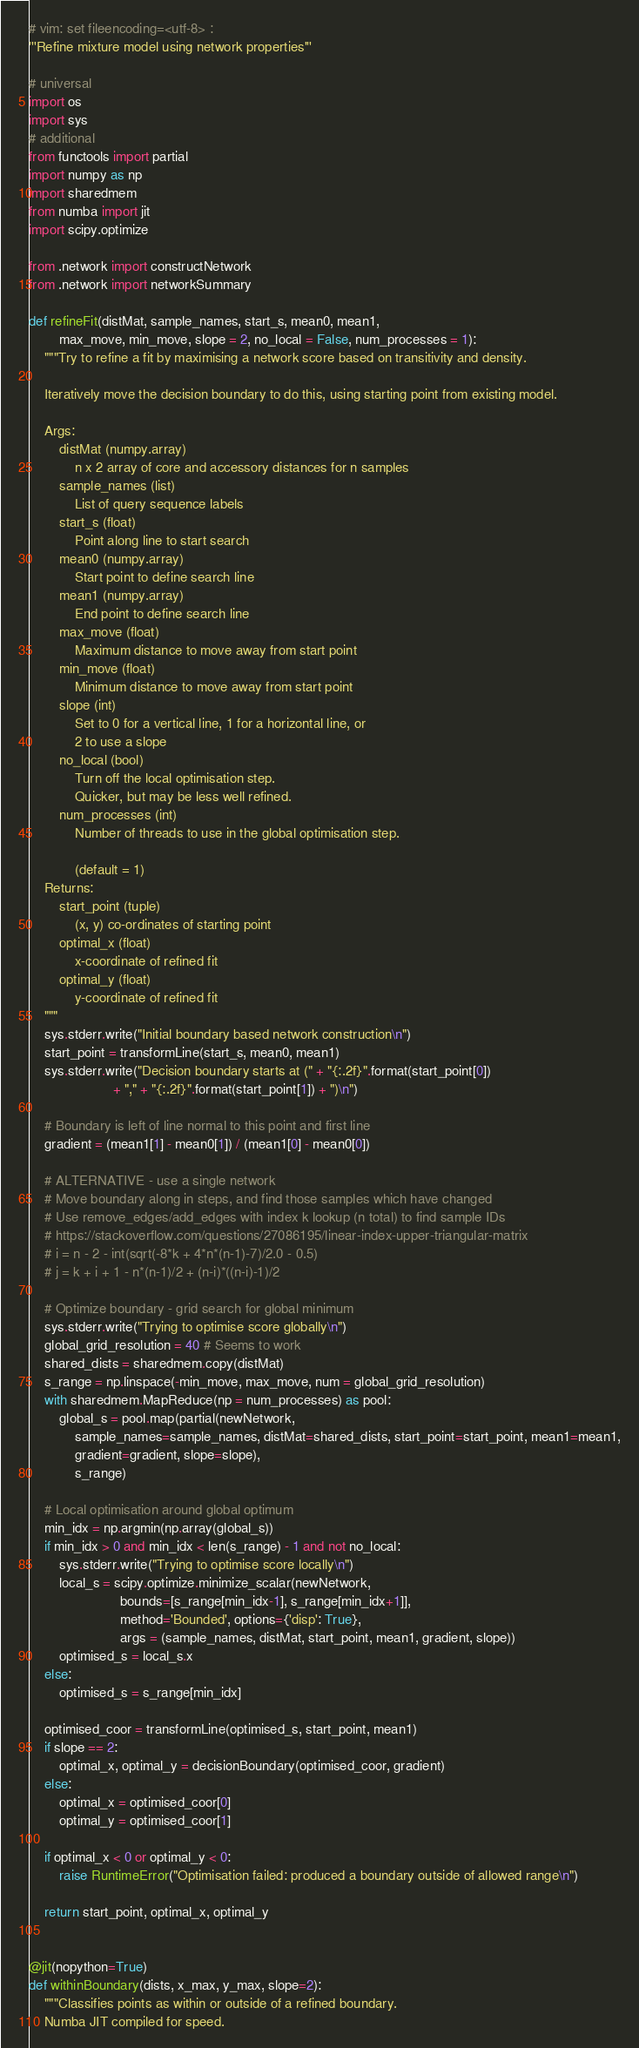Convert code to text. <code><loc_0><loc_0><loc_500><loc_500><_Python_># vim: set fileencoding=<utf-8> :
'''Refine mixture model using network properties'''

# universal
import os
import sys
# additional
from functools import partial
import numpy as np
import sharedmem
from numba import jit
import scipy.optimize

from .network import constructNetwork
from .network import networkSummary

def refineFit(distMat, sample_names, start_s, mean0, mean1,
        max_move, min_move, slope = 2, no_local = False, num_processes = 1):
    """Try to refine a fit by maximising a network score based on transitivity and density.

    Iteratively move the decision boundary to do this, using starting point from existing model.

    Args:
        distMat (numpy.array)
            n x 2 array of core and accessory distances for n samples
        sample_names (list)
            List of query sequence labels
        start_s (float)
            Point along line to start search
        mean0 (numpy.array)
            Start point to define search line
        mean1 (numpy.array)
            End point to define search line
        max_move (float)
            Maximum distance to move away from start point
        min_move (float)
            Minimum distance to move away from start point
        slope (int)
            Set to 0 for a vertical line, 1 for a horizontal line, or
            2 to use a slope
        no_local (bool)
            Turn off the local optimisation step.
            Quicker, but may be less well refined.
        num_processes (int)
            Number of threads to use in the global optimisation step.

            (default = 1)
    Returns:
        start_point (tuple)
            (x, y) co-ordinates of starting point
        optimal_x (float)
            x-coordinate of refined fit
        optimal_y (float)
            y-coordinate of refined fit
    """
    sys.stderr.write("Initial boundary based network construction\n")
    start_point = transformLine(start_s, mean0, mean1)
    sys.stderr.write("Decision boundary starts at (" + "{:.2f}".format(start_point[0])
                      + "," + "{:.2f}".format(start_point[1]) + ")\n")

    # Boundary is left of line normal to this point and first line
    gradient = (mean1[1] - mean0[1]) / (mean1[0] - mean0[0])

    # ALTERNATIVE - use a single network
    # Move boundary along in steps, and find those samples which have changed
    # Use remove_edges/add_edges with index k lookup (n total) to find sample IDs
    # https://stackoverflow.com/questions/27086195/linear-index-upper-triangular-matrix
    # i = n - 2 - int(sqrt(-8*k + 4*n*(n-1)-7)/2.0 - 0.5)
    # j = k + i + 1 - n*(n-1)/2 + (n-i)*((n-i)-1)/2

    # Optimize boundary - grid search for global minimum
    sys.stderr.write("Trying to optimise score globally\n")
    global_grid_resolution = 40 # Seems to work
    shared_dists = sharedmem.copy(distMat)
    s_range = np.linspace(-min_move, max_move, num = global_grid_resolution)
    with sharedmem.MapReduce(np = num_processes) as pool:
        global_s = pool.map(partial(newNetwork,
            sample_names=sample_names, distMat=shared_dists, start_point=start_point, mean1=mean1,
            gradient=gradient, slope=slope),
            s_range)

    # Local optimisation around global optimum
    min_idx = np.argmin(np.array(global_s))
    if min_idx > 0 and min_idx < len(s_range) - 1 and not no_local:
        sys.stderr.write("Trying to optimise score locally\n")
        local_s = scipy.optimize.minimize_scalar(newNetwork,
                        bounds=[s_range[min_idx-1], s_range[min_idx+1]],
                        method='Bounded', options={'disp': True},
                        args = (sample_names, distMat, start_point, mean1, gradient, slope))
        optimised_s = local_s.x
    else:
        optimised_s = s_range[min_idx]

    optimised_coor = transformLine(optimised_s, start_point, mean1)
    if slope == 2:
        optimal_x, optimal_y = decisionBoundary(optimised_coor, gradient)
    else:
        optimal_x = optimised_coor[0]
        optimal_y = optimised_coor[1]

    if optimal_x < 0 or optimal_y < 0:
        raise RuntimeError("Optimisation failed: produced a boundary outside of allowed range\n")

    return start_point, optimal_x, optimal_y


@jit(nopython=True)
def withinBoundary(dists, x_max, y_max, slope=2):
    """Classifies points as within or outside of a refined boundary.
    Numba JIT compiled for speed.
</code> 